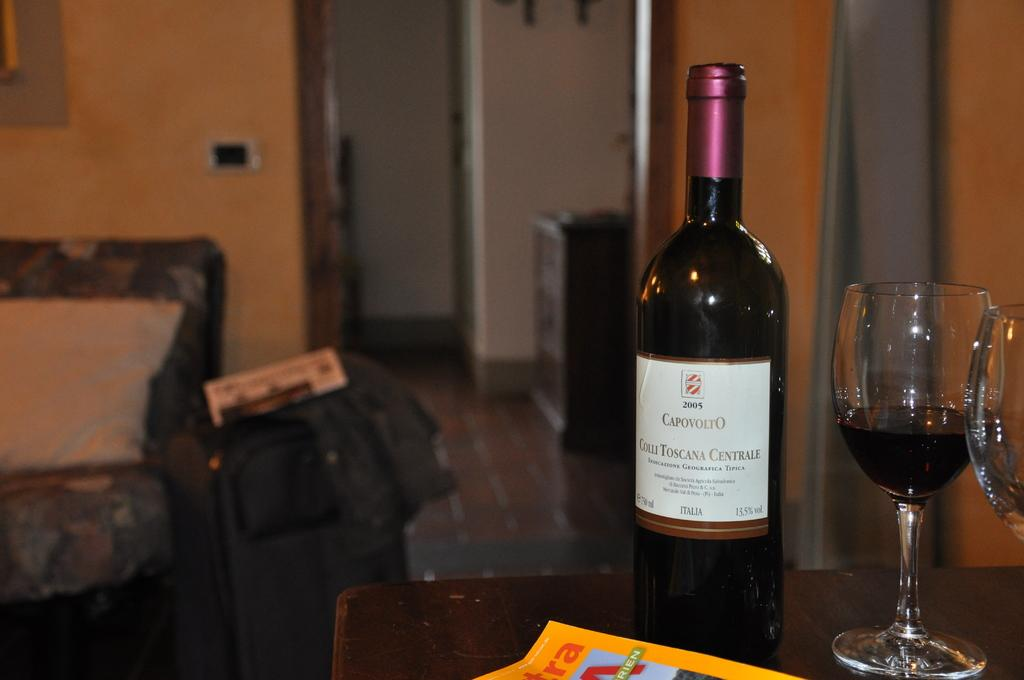Provide a one-sentence caption for the provided image. A glass of Capovolto wine sits next to the bottle. 